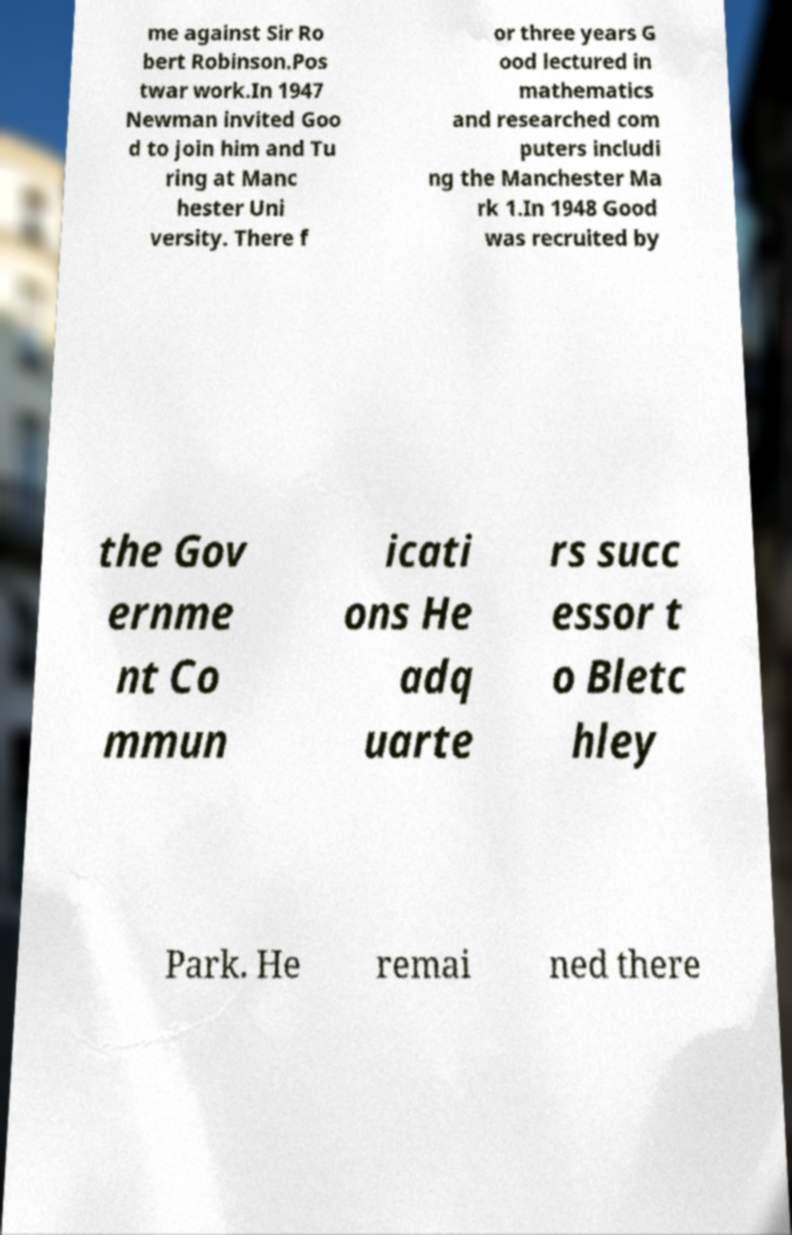Can you accurately transcribe the text from the provided image for me? me against Sir Ro bert Robinson.Pos twar work.In 1947 Newman invited Goo d to join him and Tu ring at Manc hester Uni versity. There f or three years G ood lectured in mathematics and researched com puters includi ng the Manchester Ma rk 1.In 1948 Good was recruited by the Gov ernme nt Co mmun icati ons He adq uarte rs succ essor t o Bletc hley Park. He remai ned there 